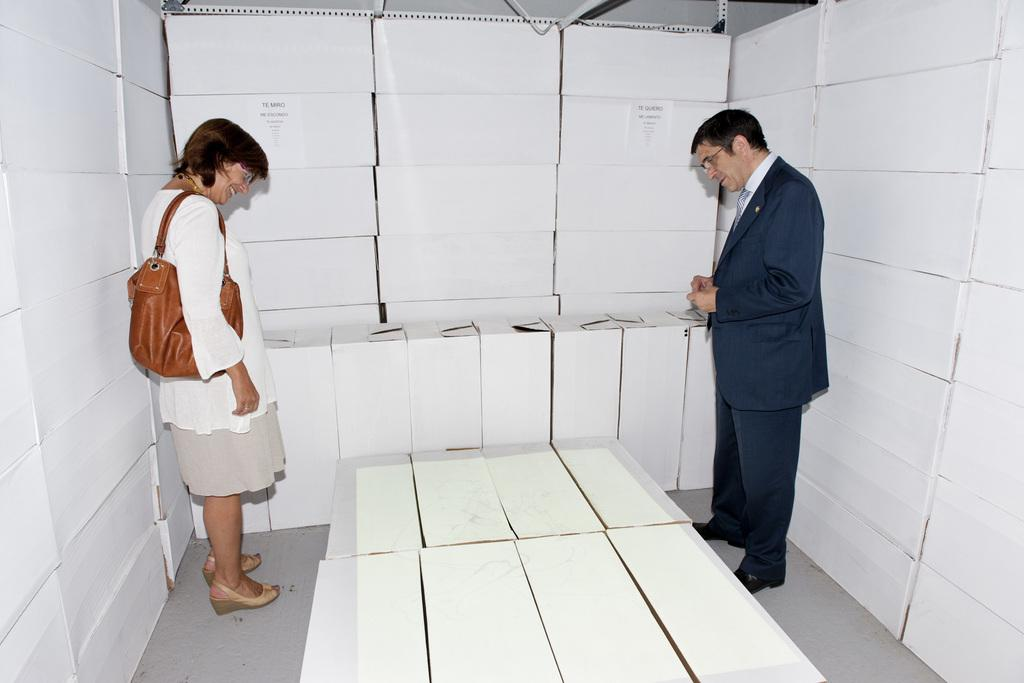What objects are present in large quantities in the image? There are many white cartons in the image. Where is the lady located in the image? The lady is standing on the left side of the image. What is the lady wearing? The lady is wearing a white top. What is the lady carrying? The lady is carrying a bag. Where is the man located in the image? The man is standing on the right side of the image. What is the man wearing? The man is wearing a blue suit. What type of attack is being carried out by the cannon in the image? There is no cannon present in the image, so no attack can be observed. Is the man's brother also present in the image? The provided facts do not mention the presence of the man's brother, so we cannot determine if he is present in the image. 